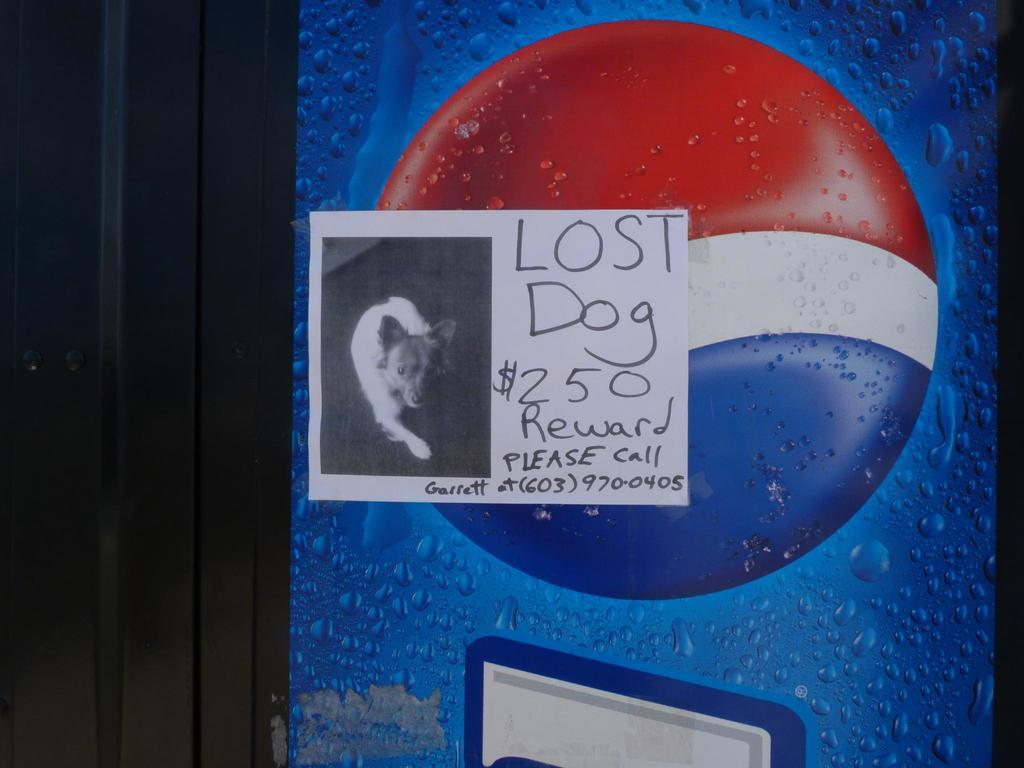What is the main subject in the center of the picture? There is a poster in the center of the picture. What is depicted on the poster? The poster features a dog. Are there any words on the poster? Yes, there is text on the poster. What brand logo can be seen in the picture? The Pepsi logo is present in the picture. What type of architectural feature is visible in the picture? There is a door in the picture. What is the size of the stage in the picture? There is no stage present in the picture; it features a poster with a dog and text, the Pepsi logo, and a door. 